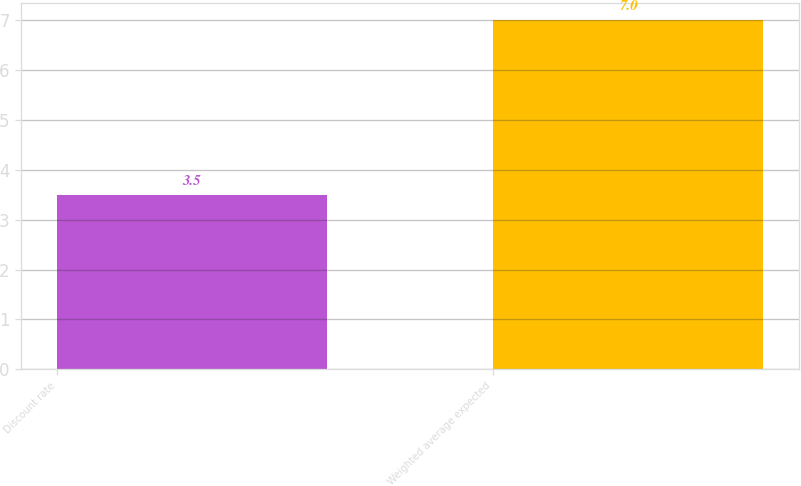Convert chart to OTSL. <chart><loc_0><loc_0><loc_500><loc_500><bar_chart><fcel>Discount rate<fcel>Weighted average expected<nl><fcel>3.5<fcel>7<nl></chart> 